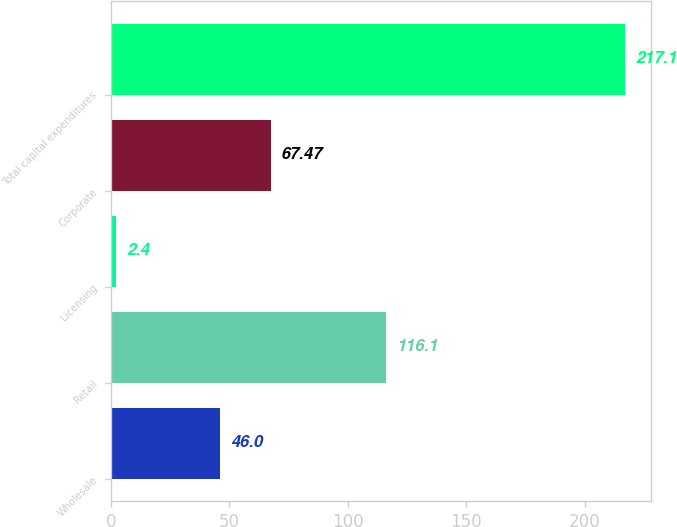Convert chart to OTSL. <chart><loc_0><loc_0><loc_500><loc_500><bar_chart><fcel>Wholesale<fcel>Retail<fcel>Licensing<fcel>Corporate<fcel>Total capital expenditures<nl><fcel>46<fcel>116.1<fcel>2.4<fcel>67.47<fcel>217.1<nl></chart> 